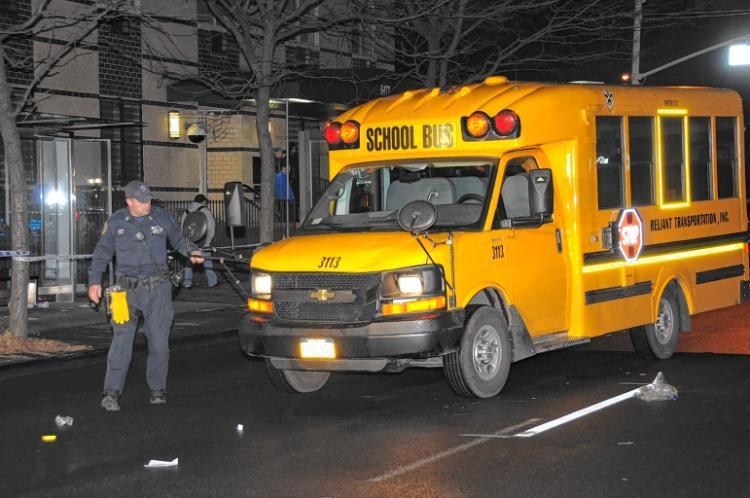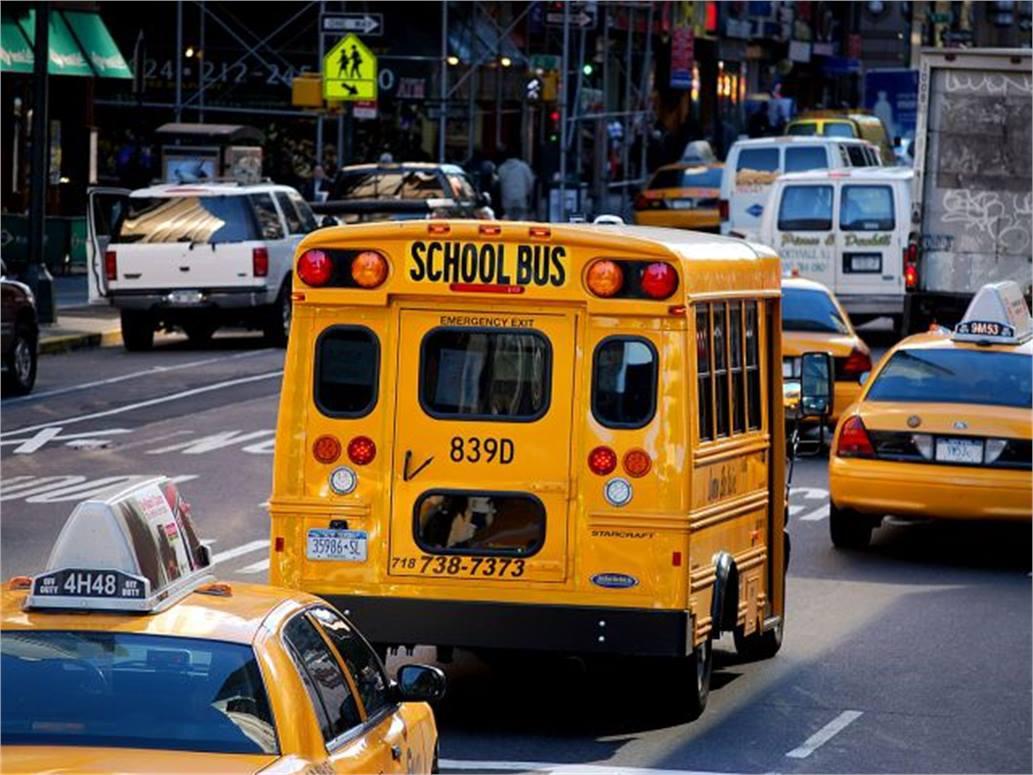The first image is the image on the left, the second image is the image on the right. For the images shown, is this caption "One image shows a short leftward headed non-flat school bus with no more than five passenger windows per side, and the other image shows a short rightward angled bus from the rear." true? Answer yes or no. Yes. The first image is the image on the left, the second image is the image on the right. Considering the images on both sides, is "There are exactly two school buses." valid? Answer yes or no. Yes. 